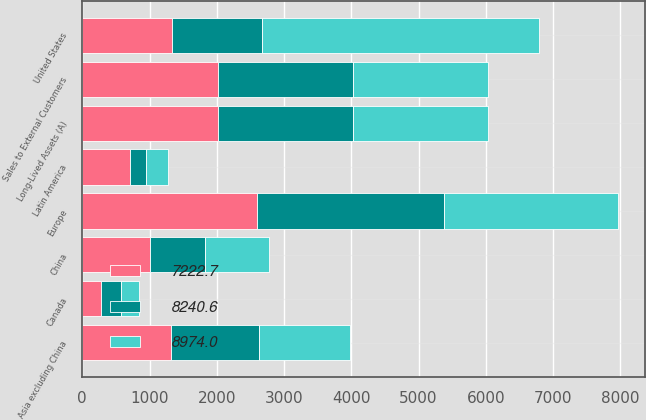<chart> <loc_0><loc_0><loc_500><loc_500><stacked_bar_chart><ecel><fcel>Sales to External Customers<fcel>United States<fcel>Canada<fcel>Europe<fcel>Asia excluding China<fcel>China<fcel>Latin America<fcel>Long-Lived Assets (A)<nl><fcel>7222.7<fcel>2013<fcel>1335<fcel>275.5<fcel>2602.1<fcel>1320.1<fcel>1008.3<fcel>716<fcel>2013<nl><fcel>8974<fcel>2012<fcel>4114.5<fcel>267.6<fcel>2588.5<fcel>1349.9<fcel>954.1<fcel>337.1<fcel>2012<nl><fcel>8240.6<fcel>2011<fcel>1335<fcel>297<fcel>2773.8<fcel>1307.9<fcel>814.2<fcel>228.3<fcel>2011<nl></chart> 